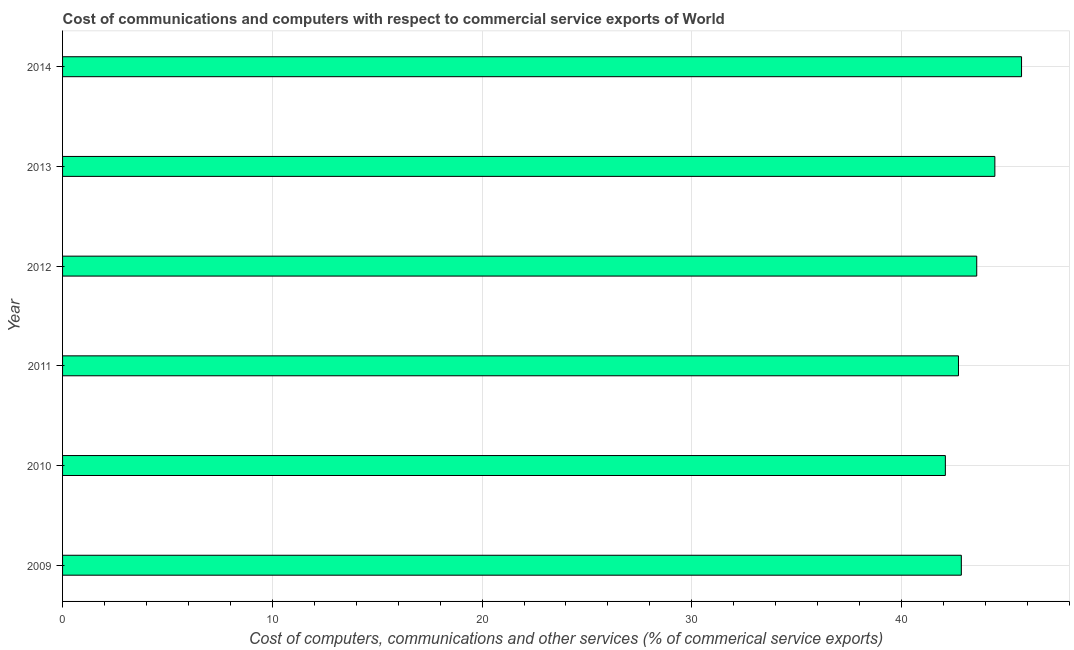Does the graph contain grids?
Your answer should be very brief. Yes. What is the title of the graph?
Your answer should be compact. Cost of communications and computers with respect to commercial service exports of World. What is the label or title of the X-axis?
Keep it short and to the point. Cost of computers, communications and other services (% of commerical service exports). What is the label or title of the Y-axis?
Your answer should be compact. Year. What is the  computer and other services in 2009?
Your response must be concise. 42.85. Across all years, what is the maximum  computer and other services?
Keep it short and to the point. 45.72. Across all years, what is the minimum cost of communications?
Ensure brevity in your answer.  42.09. In which year was the  computer and other services maximum?
Your answer should be compact. 2014. What is the sum of the cost of communications?
Offer a very short reply. 261.41. What is the difference between the cost of communications in 2012 and 2014?
Offer a terse response. -2.14. What is the average cost of communications per year?
Ensure brevity in your answer.  43.57. What is the median  computer and other services?
Give a very brief answer. 43.22. In how many years, is the cost of communications greater than 32 %?
Offer a very short reply. 6. What is the ratio of the cost of communications in 2009 to that in 2014?
Offer a very short reply. 0.94. Is the cost of communications in 2010 less than that in 2014?
Your response must be concise. Yes. Is the difference between the  computer and other services in 2013 and 2014 greater than the difference between any two years?
Provide a succinct answer. No. What is the difference between the highest and the second highest  computer and other services?
Ensure brevity in your answer.  1.27. Is the sum of the  computer and other services in 2013 and 2014 greater than the maximum  computer and other services across all years?
Provide a short and direct response. Yes. What is the difference between the highest and the lowest  computer and other services?
Provide a short and direct response. 3.63. Are all the bars in the graph horizontal?
Offer a very short reply. Yes. What is the difference between two consecutive major ticks on the X-axis?
Offer a terse response. 10. What is the Cost of computers, communications and other services (% of commerical service exports) in 2009?
Offer a very short reply. 42.85. What is the Cost of computers, communications and other services (% of commerical service exports) in 2010?
Your answer should be very brief. 42.09. What is the Cost of computers, communications and other services (% of commerical service exports) in 2011?
Make the answer very short. 42.71. What is the Cost of computers, communications and other services (% of commerical service exports) of 2012?
Your response must be concise. 43.59. What is the Cost of computers, communications and other services (% of commerical service exports) in 2013?
Provide a short and direct response. 44.45. What is the Cost of computers, communications and other services (% of commerical service exports) of 2014?
Ensure brevity in your answer.  45.72. What is the difference between the Cost of computers, communications and other services (% of commerical service exports) in 2009 and 2010?
Your answer should be very brief. 0.76. What is the difference between the Cost of computers, communications and other services (% of commerical service exports) in 2009 and 2011?
Your answer should be compact. 0.14. What is the difference between the Cost of computers, communications and other services (% of commerical service exports) in 2009 and 2012?
Your answer should be very brief. -0.73. What is the difference between the Cost of computers, communications and other services (% of commerical service exports) in 2009 and 2013?
Ensure brevity in your answer.  -1.6. What is the difference between the Cost of computers, communications and other services (% of commerical service exports) in 2009 and 2014?
Give a very brief answer. -2.87. What is the difference between the Cost of computers, communications and other services (% of commerical service exports) in 2010 and 2011?
Offer a very short reply. -0.62. What is the difference between the Cost of computers, communications and other services (% of commerical service exports) in 2010 and 2012?
Your answer should be compact. -1.5. What is the difference between the Cost of computers, communications and other services (% of commerical service exports) in 2010 and 2013?
Your answer should be very brief. -2.36. What is the difference between the Cost of computers, communications and other services (% of commerical service exports) in 2010 and 2014?
Offer a terse response. -3.63. What is the difference between the Cost of computers, communications and other services (% of commerical service exports) in 2011 and 2012?
Your answer should be very brief. -0.87. What is the difference between the Cost of computers, communications and other services (% of commerical service exports) in 2011 and 2013?
Your response must be concise. -1.74. What is the difference between the Cost of computers, communications and other services (% of commerical service exports) in 2011 and 2014?
Provide a short and direct response. -3.01. What is the difference between the Cost of computers, communications and other services (% of commerical service exports) in 2012 and 2013?
Provide a short and direct response. -0.86. What is the difference between the Cost of computers, communications and other services (% of commerical service exports) in 2012 and 2014?
Offer a very short reply. -2.14. What is the difference between the Cost of computers, communications and other services (% of commerical service exports) in 2013 and 2014?
Your answer should be very brief. -1.27. What is the ratio of the Cost of computers, communications and other services (% of commerical service exports) in 2009 to that in 2010?
Provide a short and direct response. 1.02. What is the ratio of the Cost of computers, communications and other services (% of commerical service exports) in 2009 to that in 2011?
Your response must be concise. 1. What is the ratio of the Cost of computers, communications and other services (% of commerical service exports) in 2009 to that in 2014?
Offer a terse response. 0.94. What is the ratio of the Cost of computers, communications and other services (% of commerical service exports) in 2010 to that in 2013?
Provide a succinct answer. 0.95. What is the ratio of the Cost of computers, communications and other services (% of commerical service exports) in 2010 to that in 2014?
Ensure brevity in your answer.  0.92. What is the ratio of the Cost of computers, communications and other services (% of commerical service exports) in 2011 to that in 2012?
Your response must be concise. 0.98. What is the ratio of the Cost of computers, communications and other services (% of commerical service exports) in 2011 to that in 2014?
Your response must be concise. 0.93. What is the ratio of the Cost of computers, communications and other services (% of commerical service exports) in 2012 to that in 2013?
Make the answer very short. 0.98. What is the ratio of the Cost of computers, communications and other services (% of commerical service exports) in 2012 to that in 2014?
Provide a short and direct response. 0.95. 